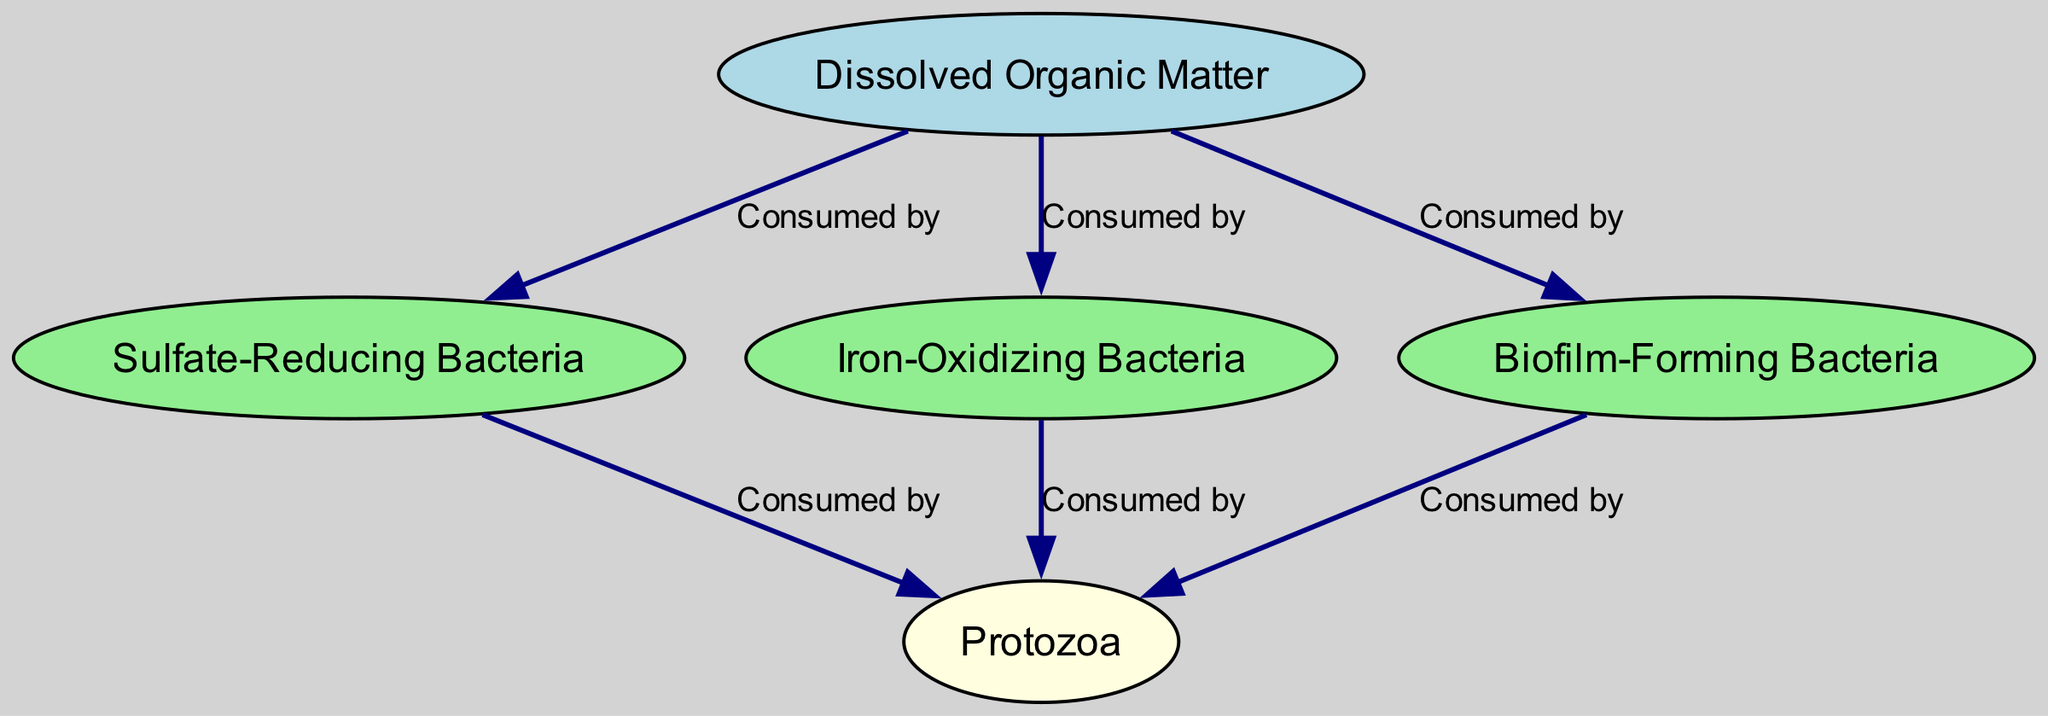What is the total number of nodes in the diagram? The diagram includes five distinct entities: Dissolved Organic Matter, Sulfate-Reducing Bacteria, Iron-Oxidizing Bacteria, Biofilm-Forming Bacteria, and Protozoa. Counting these gives a total of five nodes.
Answer: 5 Which organism consumes Dissolved Organic Matter? The edges indicate that Dissolved Organic Matter is consumed by three organisms: Sulfate-Reducing Bacteria, Iron-Oxidizing Bacteria, and Biofilm-Forming Bacteria.
Answer: Sulfate-Reducing Bacteria, Iron-Oxidizing Bacteria, Biofilm-Forming Bacteria How many types of bacteria are present in the food web? There are three types of bacteria in the diagram: Sulfate-Reducing Bacteria, Iron-Oxidizing Bacteria, and Biofilm-Forming Bacteria.
Answer: 3 Which organism is a primary consumer in this food web? The primary consumers are organisms that directly consume the primary producers. In this case, the organisms consuming Dissolved Organic Matter fulfill this role, namely Sulfate-Reducing Bacteria, Iron-Oxidizing Bacteria, and Biofilm-Forming Bacteria.
Answer: Sulfate-Reducing Bacteria, Iron-Oxidizing Bacteria, Biofilm-Forming Bacteria How many organisms consume Protozoa? Looking at the edges in the diagram, it's evident that Protozoa is represented as a consumer and has three sources from which it derives: Sulfate-Reducing Bacteria, Iron-Oxidizing Bacteria, and Biofilm-Forming Bacteria. Thus, three organisms consume Protozoa.
Answer: 3 Which type of bacteria does not directly consume any other organisms in this web? Since the only node not represented as a source for any edge is Protozoa, it indicates that Protozoa does not consume any other organisms within this food web.
Answer: Protozoa What does the arrow from Dissolved Organic Matter represent in terms of interactions? Each arrow in the diagram symbolizes a consumption interaction. Therefore, the arrows from Dissolved Organic Matter directed toward the various bacteria indicate that these bacteria consume Dissolved Organic Matter.
Answer: Consumed by Which organism is at the top of the food chain? The top of the food chain in this diagram is represented by Protozoa, as it is the last node in the interactions, indicating that it consumes multiple types of bacteria but is not consumed by any other organism in the chain.
Answer: Protozoa 